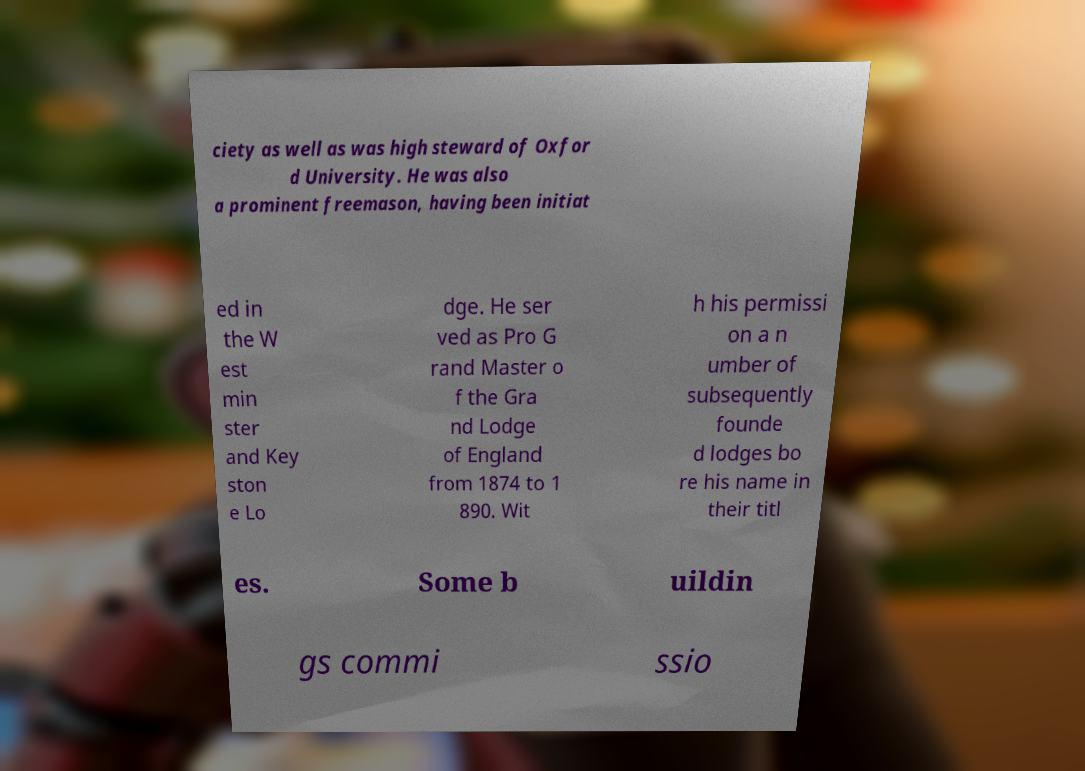I need the written content from this picture converted into text. Can you do that? ciety as well as was high steward of Oxfor d University. He was also a prominent freemason, having been initiat ed in the W est min ster and Key ston e Lo dge. He ser ved as Pro G rand Master o f the Gra nd Lodge of England from 1874 to 1 890. Wit h his permissi on a n umber of subsequently founde d lodges bo re his name in their titl es. Some b uildin gs commi ssio 